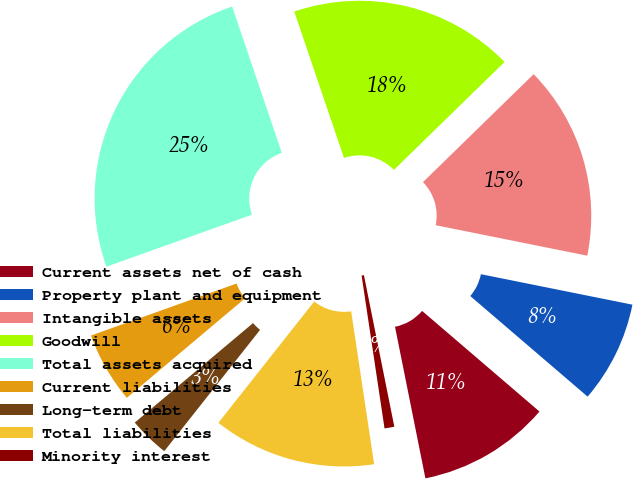Convert chart to OTSL. <chart><loc_0><loc_0><loc_500><loc_500><pie_chart><fcel>Current assets net of cash<fcel>Property plant and equipment<fcel>Intangible assets<fcel>Goodwill<fcel>Total assets acquired<fcel>Current liabilities<fcel>Long-term debt<fcel>Total liabilities<fcel>Minority interest<nl><fcel>10.57%<fcel>8.12%<fcel>15.46%<fcel>17.91%<fcel>25.25%<fcel>5.67%<fcel>3.23%<fcel>13.01%<fcel>0.78%<nl></chart> 